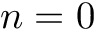Convert formula to latex. <formula><loc_0><loc_0><loc_500><loc_500>n = 0</formula> 